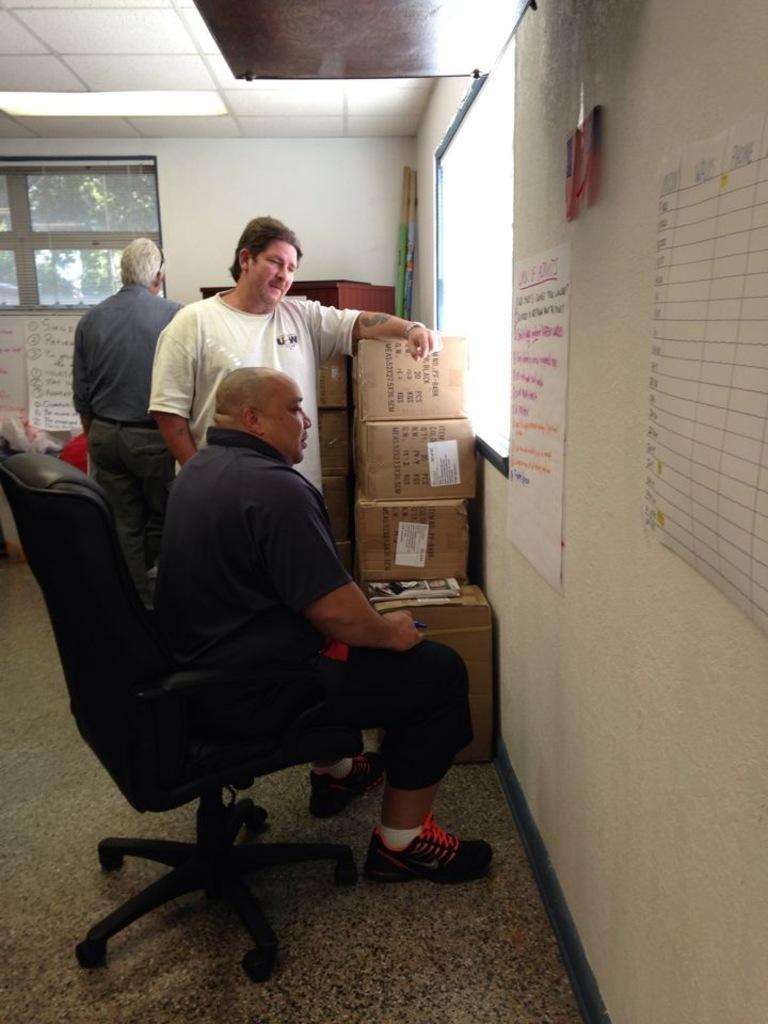In one or two sentences, can you explain what this image depicts? In this picture, There is a chair which is in black color on that chair there is a man sitting and there are some people standing, In the right side there is a wall which are in white color and there are some poster pasted on the wall, There is a window in white color. 